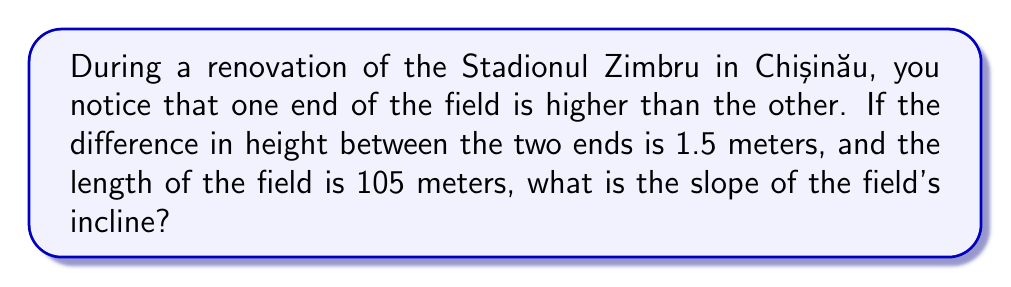Solve this math problem. Let's approach this step-by-step:

1) The slope of a line is defined as the change in y (vertical distance) divided by the change in x (horizontal distance). In mathematical terms:

   $$ \text{slope} = \frac{\text{rise}}{\text{run}} = \frac{\Delta y}{\Delta x} $$

2) In this case:
   - The rise (Δy) is the difference in height: 1.5 meters
   - The run (Δx) is the length of the field: 105 meters

3) Plugging these values into our slope formula:

   $$ \text{slope} = \frac{1.5 \text{ m}}{105 \text{ m}} $$

4) Simplify the fraction:

   $$ \text{slope} = \frac{3}{210} = \frac{1}{70} $$

5) This can be expressed as a decimal by dividing 1 by 70:

   $$ \text{slope} \approx 0.0143 $$

The slope can be expressed as a fraction (1/70) or as a decimal (0.0143).
Answer: $\frac{1}{70}$ or $0.0143$ 